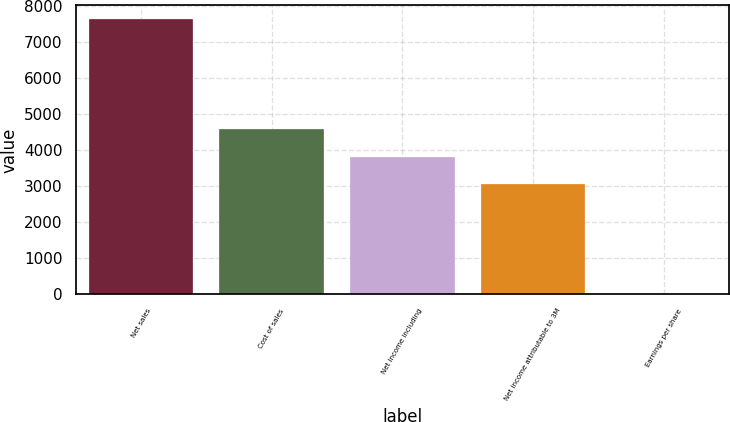Convert chart. <chart><loc_0><loc_0><loc_500><loc_500><bar_chart><fcel>Net sales<fcel>Cost of sales<fcel>Net income including<fcel>Net income attributable to 3M<fcel>Earnings per share<nl><fcel>7634<fcel>4581.03<fcel>3817.79<fcel>3054.55<fcel>1.59<nl></chart> 